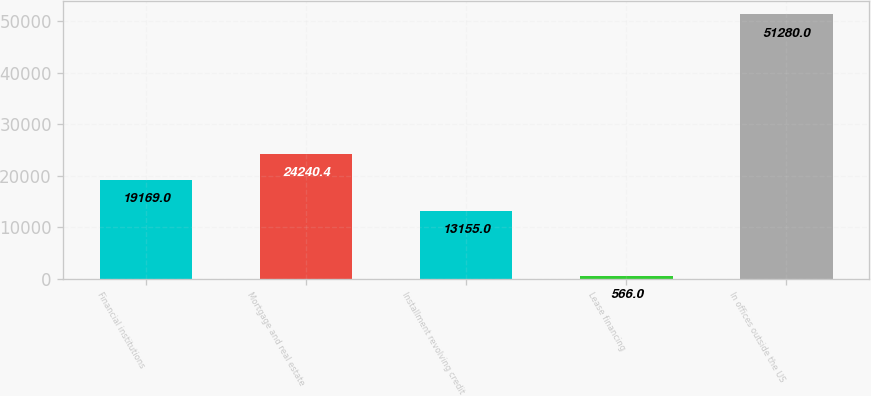Convert chart to OTSL. <chart><loc_0><loc_0><loc_500><loc_500><bar_chart><fcel>Financial institutions<fcel>Mortgage and real estate<fcel>Installment revolving credit<fcel>Lease financing<fcel>In offices outside the US<nl><fcel>19169<fcel>24240.4<fcel>13155<fcel>566<fcel>51280<nl></chart> 